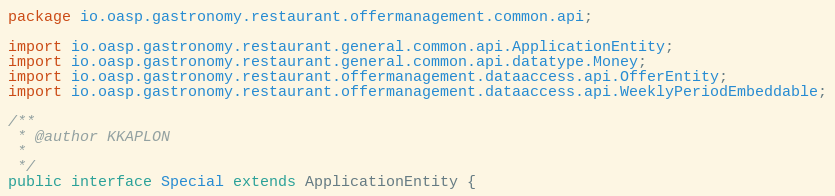<code> <loc_0><loc_0><loc_500><loc_500><_Java_>package io.oasp.gastronomy.restaurant.offermanagement.common.api;

import io.oasp.gastronomy.restaurant.general.common.api.ApplicationEntity;
import io.oasp.gastronomy.restaurant.general.common.api.datatype.Money;
import io.oasp.gastronomy.restaurant.offermanagement.dataaccess.api.OfferEntity;
import io.oasp.gastronomy.restaurant.offermanagement.dataaccess.api.WeeklyPeriodEmbeddable;

/**
 * @author KKAPLON
 *
 */
public interface Special extends ApplicationEntity {
</code> 